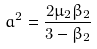Convert formula to latex. <formula><loc_0><loc_0><loc_500><loc_500>a ^ { 2 } = \frac { 2 \mu _ { 2 } \beta _ { 2 } } { 3 - \beta _ { 2 } }</formula> 